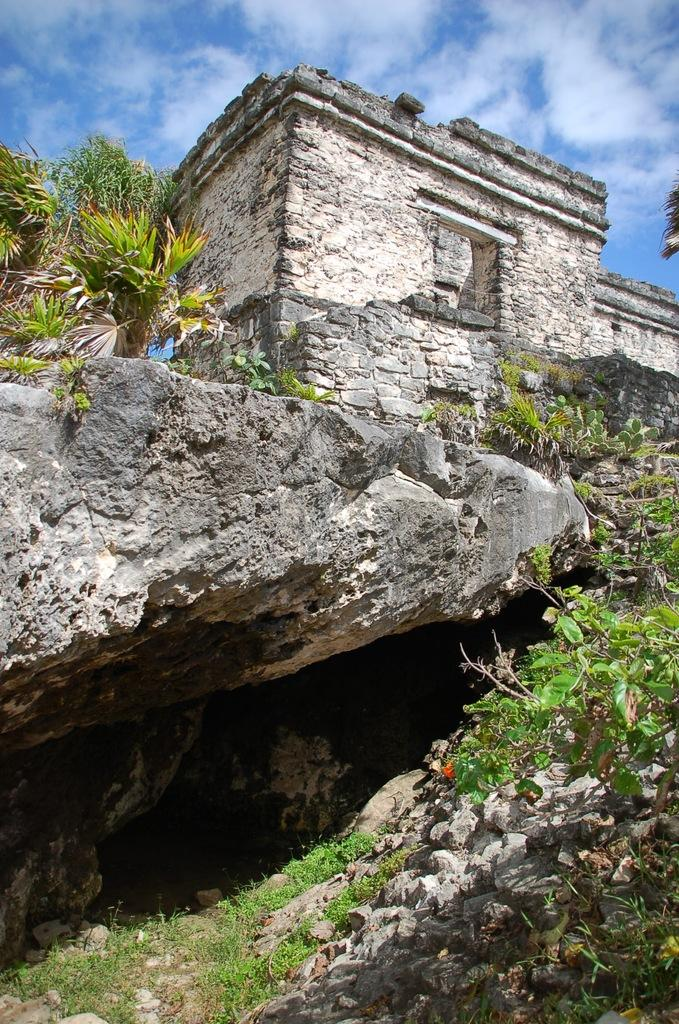What is the main structure in the image? There is a building on a rock in the image. What can be seen near the building? There are plants near the building. What is visible in the background of the image? The sky is visible in the background of the image. What can be observed in the sky? Clouds are present in the sky. How many members are on the team that built the building in the image? There is no information about a team or the number of members in the image. 